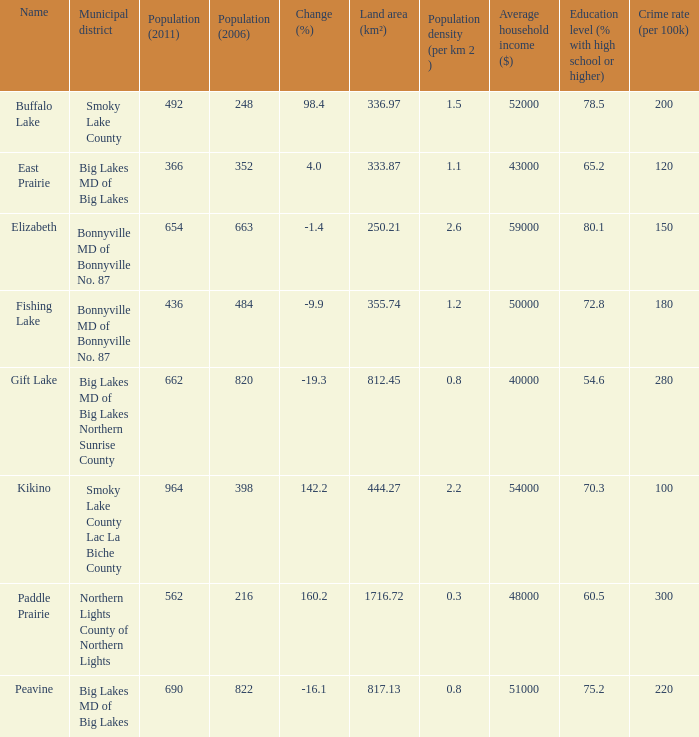What is the density per km in Smoky Lake County? 1.5. 